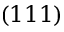<formula> <loc_0><loc_0><loc_500><loc_500>( 1 1 1 )</formula> 